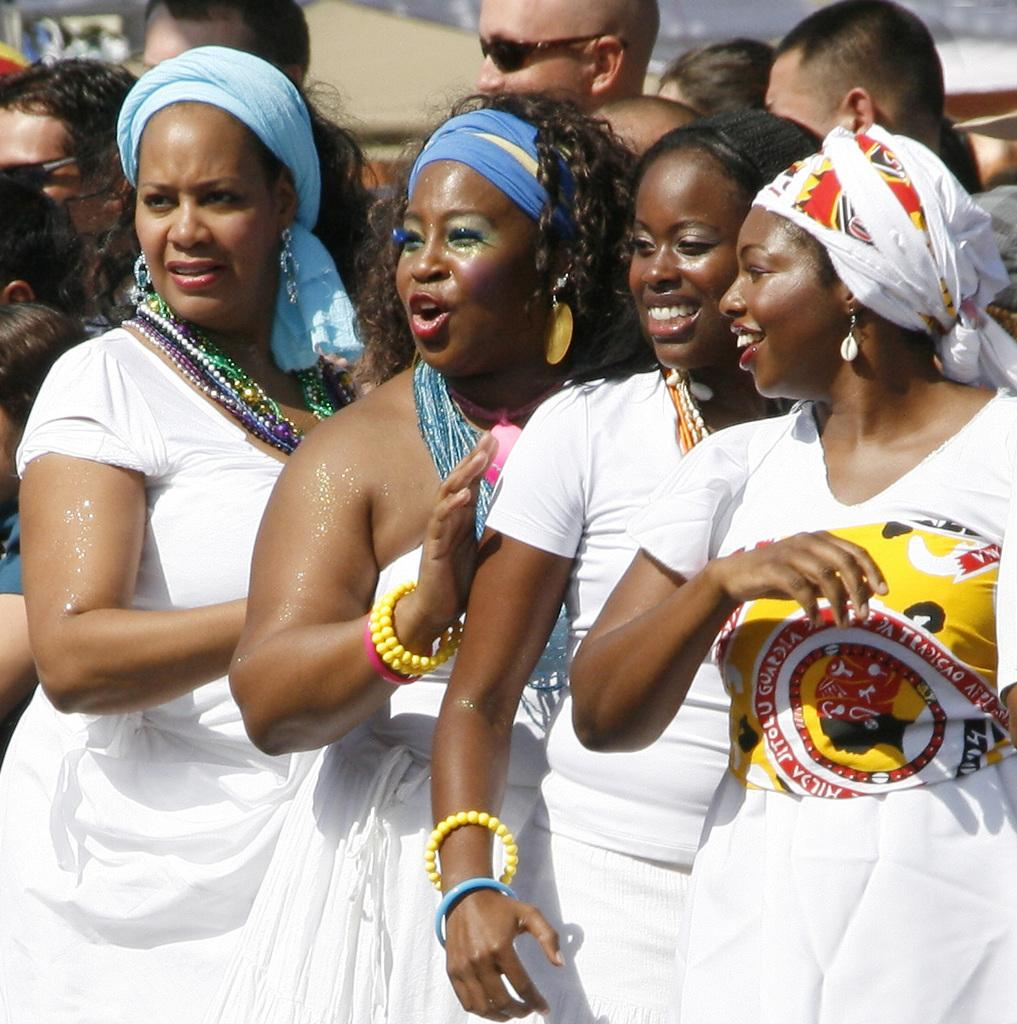How many people are present in the image? There are persons in the image, but the exact number cannot be determined from the provided facts. What else can be seen in the image besides the persons? There are other objects in the background of the image. What type of iron is being used by the girls in the image? There is no mention of an iron or girls in the image, so this question cannot be answered. 